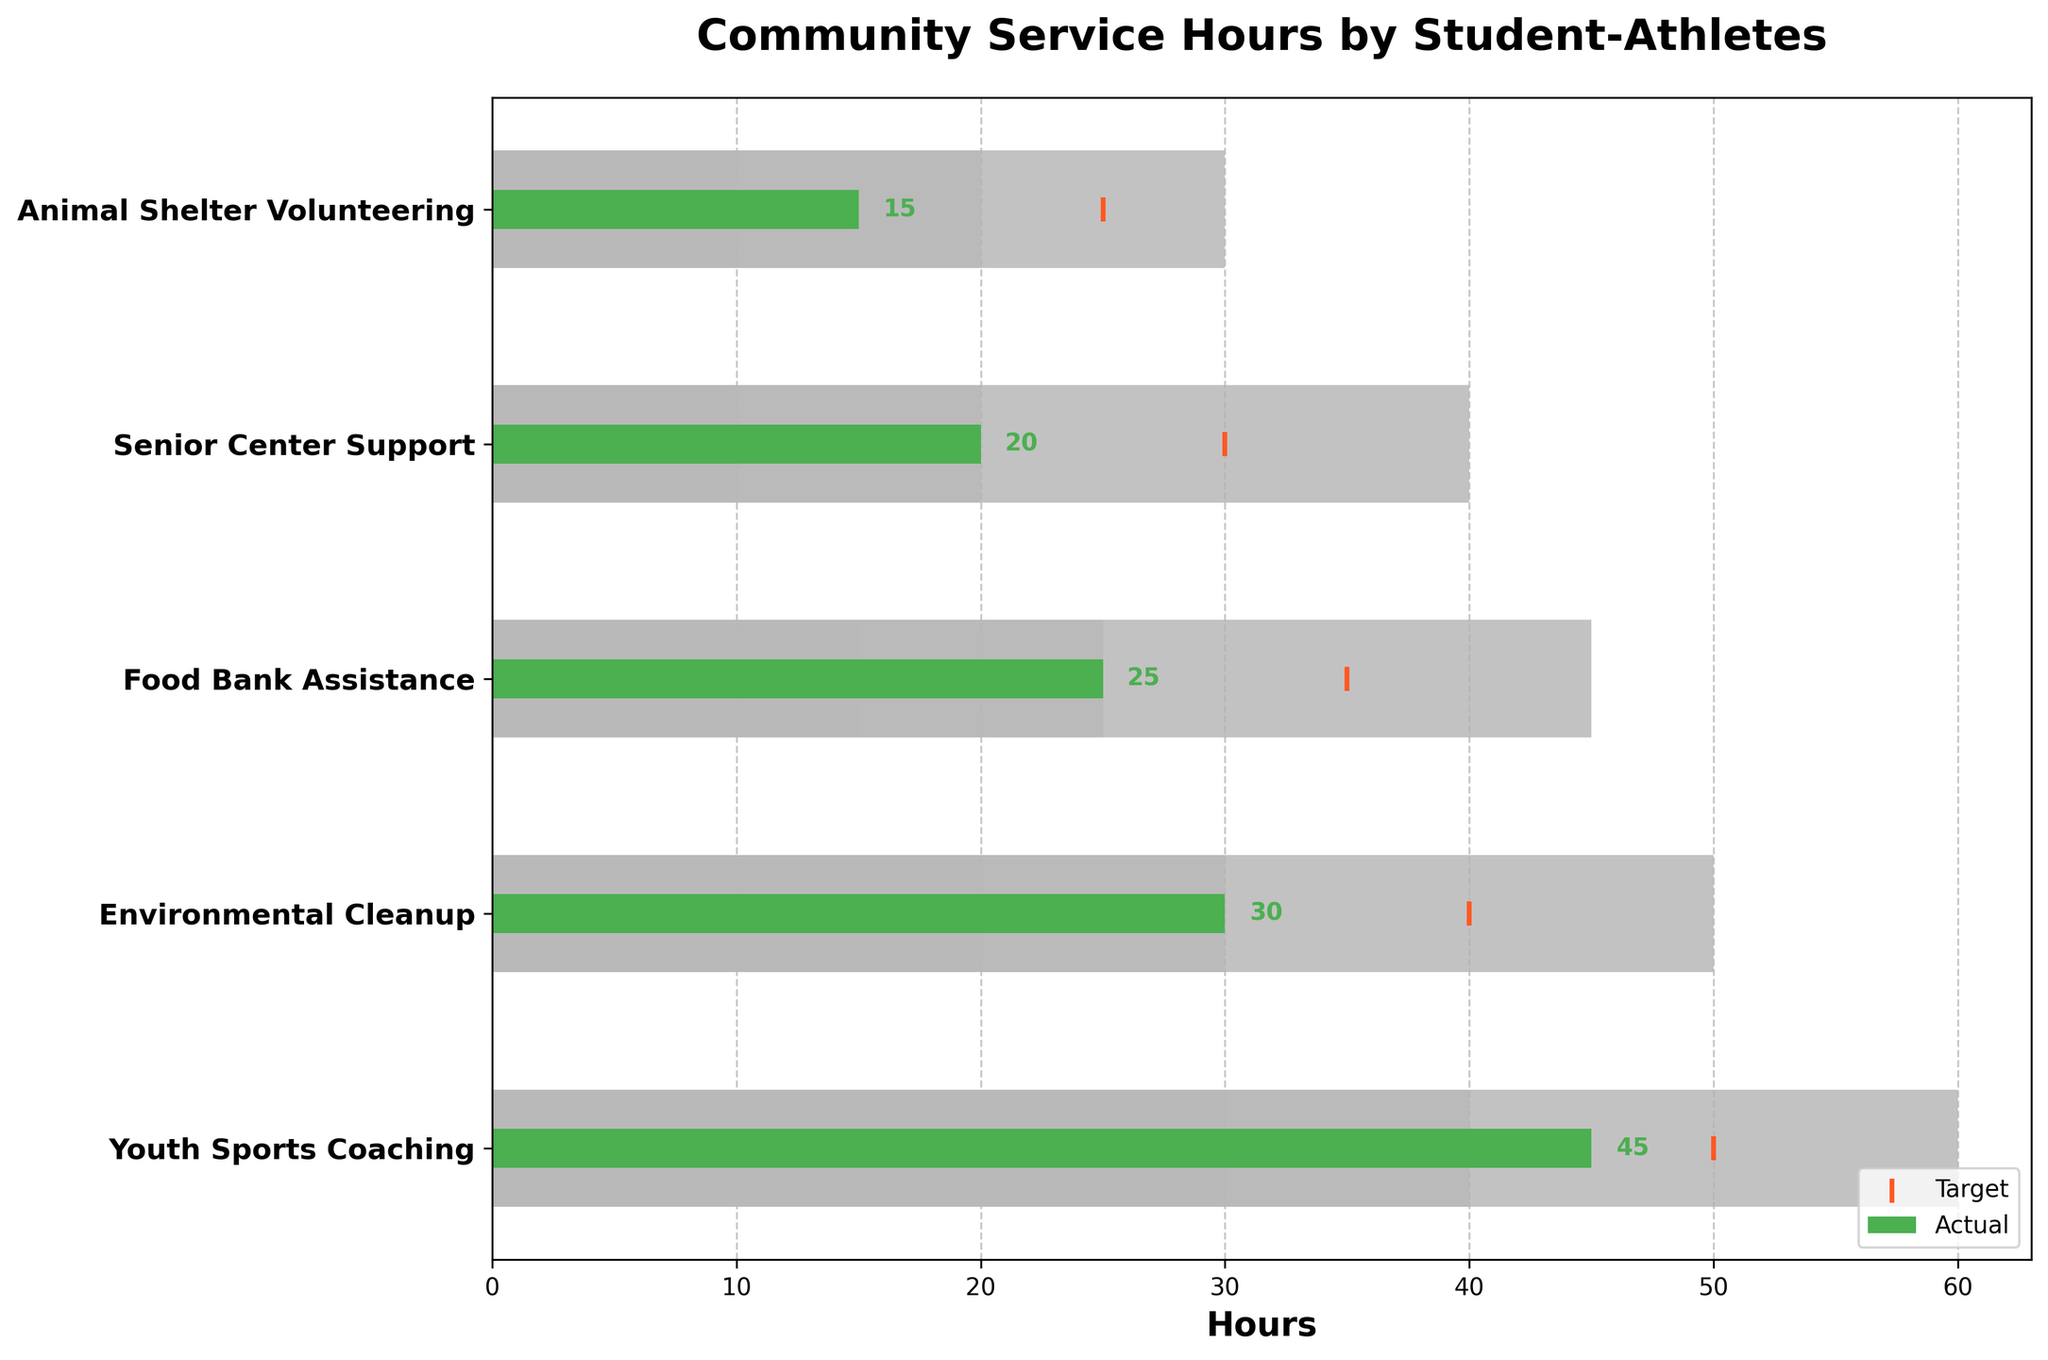What is the title of the chart? The title of the chart is displayed at the top center and is usually in a larger font size.
Answer: Community Service Hours by Student-Athletes How many categories of volunteer work are shown in the chart? Count the number of different bars, each representing a unique category of volunteer work.
Answer: 5 Which category has the highest actual community service hours? Compare the lengths of the green bars representing the actual hours across all categories.
Answer: Youth Sports Coaching What is the target community service hours for Environmental Cleanup? Look for the orange marker along the Environmental Cleanup row, which indicates the target hours.
Answer: 40 How much more community service hours does Youth Sports Coaching have compared to Senior Center Support? Subtract the actual hours of Senior Center Support from Youth Sports Coaching: 45 - 20 = 25.
Answer: 25 Which volunteer activity is furthest from reaching its target? Measure the difference between the actual hours (green bar) and the target (orange marker) for each category, finding the largest gap.
Answer: Animal Shelter Volunteering What is the overall range of hours for Food Bank Assistance that is considered satisfactory? Identify the range which includes the target hours and their boundaries (in this case, Range 3 for satisfactory): 25 to 35.
Answer: 25 to 35 How many hours are within the "good" range for Senior Center Support? Identify the "good" range as the second set of bars (gray color) for Senior Center Support, which is between 20 and 30 hours.
Answer: 10 Which activity has exceeded its 'good' range but hasn't met the 'excellent' target? Compare the actual hours to the 'good' range and 'excellent' range across categories; Youth Sports Coaching has 45 hours, which is beyond its 'good' range (30-40) but not 'excellent' (40-60).
Answer: Youth Sports Coaching 